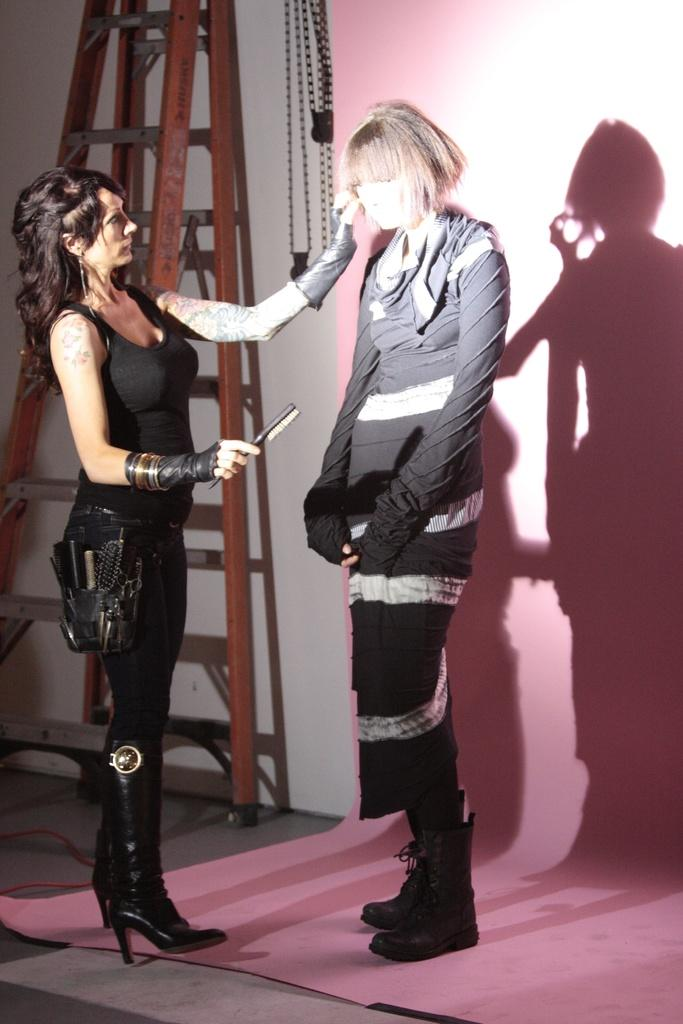Who is the main subject in the image? There is a woman in the image. What is the woman doing in the image? The woman is standing in front of a statue. What can be seen in the background of the image? There is a wall and a ladder in the background of the image. What type of steam is coming out of the statue in the image? There is no steam coming out of the statue in the image; it is a statue and does not produce steam. 